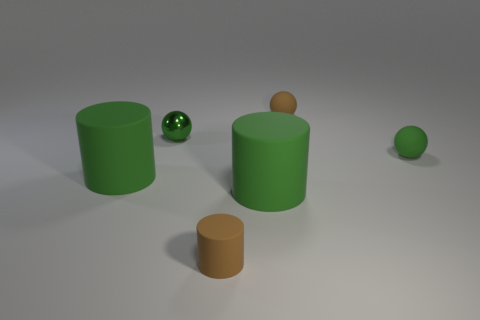Does the small green sphere that is left of the brown ball have the same material as the small cylinder?
Your answer should be compact. No. There is a green object that is behind the green rubber ball; what material is it?
Offer a very short reply. Metal. How many green things are rubber spheres or tiny matte things?
Provide a short and direct response. 1. Is there anything else that is the same color as the small rubber cylinder?
Make the answer very short. Yes. What is the color of the object right of the small matte ball that is to the left of the tiny green rubber sphere?
Your response must be concise. Green. Are there fewer balls in front of the metal sphere than green rubber cylinders in front of the tiny green rubber sphere?
Make the answer very short. Yes. There is a tiny thing that is the same color as the tiny cylinder; what is its material?
Give a very brief answer. Rubber. What number of things are either brown rubber things behind the small metal object or purple metallic things?
Make the answer very short. 1. There is a green thing that is behind the green matte ball; is its size the same as the brown rubber cylinder?
Your response must be concise. Yes. Is the number of tiny rubber balls behind the tiny green metallic sphere less than the number of small shiny balls?
Your response must be concise. No. 